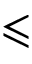<formula> <loc_0><loc_0><loc_500><loc_500>\leqslant</formula> 